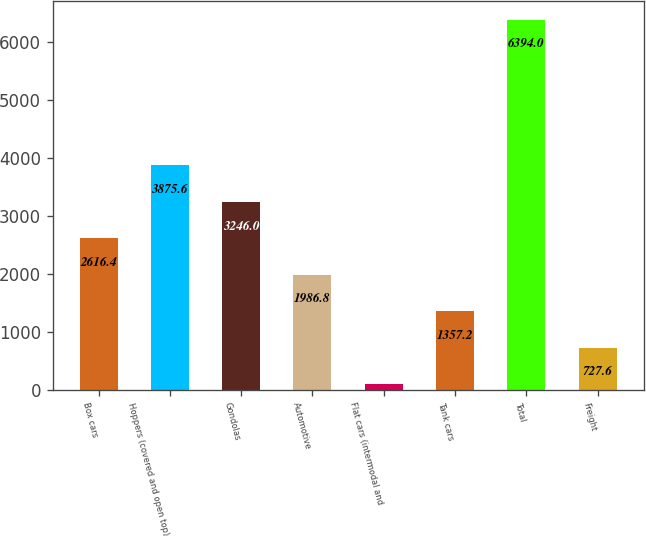Convert chart. <chart><loc_0><loc_0><loc_500><loc_500><bar_chart><fcel>Box cars<fcel>Hoppers (covered and open top)<fcel>Gondolas<fcel>Automotive<fcel>Flat cars (intermodal and<fcel>Tank cars<fcel>Total<fcel>Freight<nl><fcel>2616.4<fcel>3875.6<fcel>3246<fcel>1986.8<fcel>98<fcel>1357.2<fcel>6394<fcel>727.6<nl></chart> 